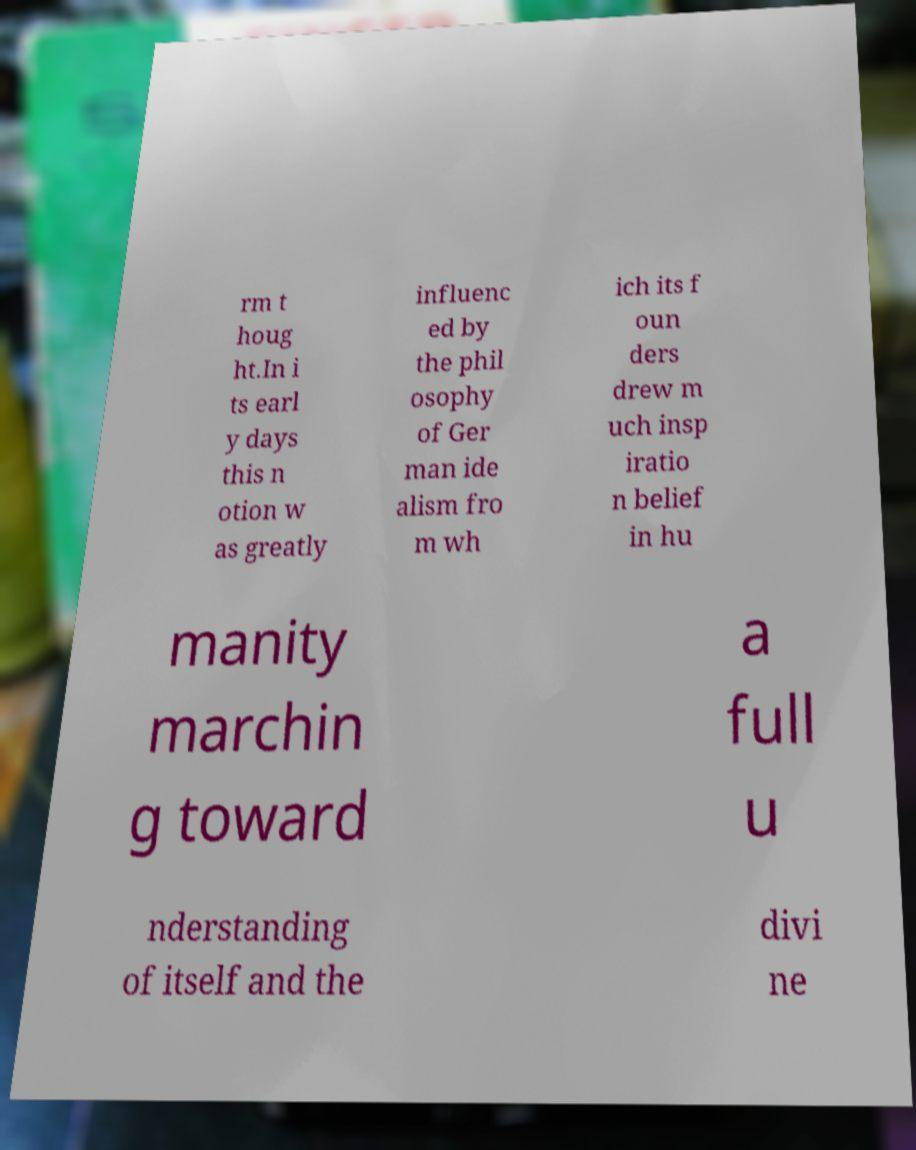I need the written content from this picture converted into text. Can you do that? rm t houg ht.In i ts earl y days this n otion w as greatly influenc ed by the phil osophy of Ger man ide alism fro m wh ich its f oun ders drew m uch insp iratio n belief in hu manity marchin g toward a full u nderstanding of itself and the divi ne 